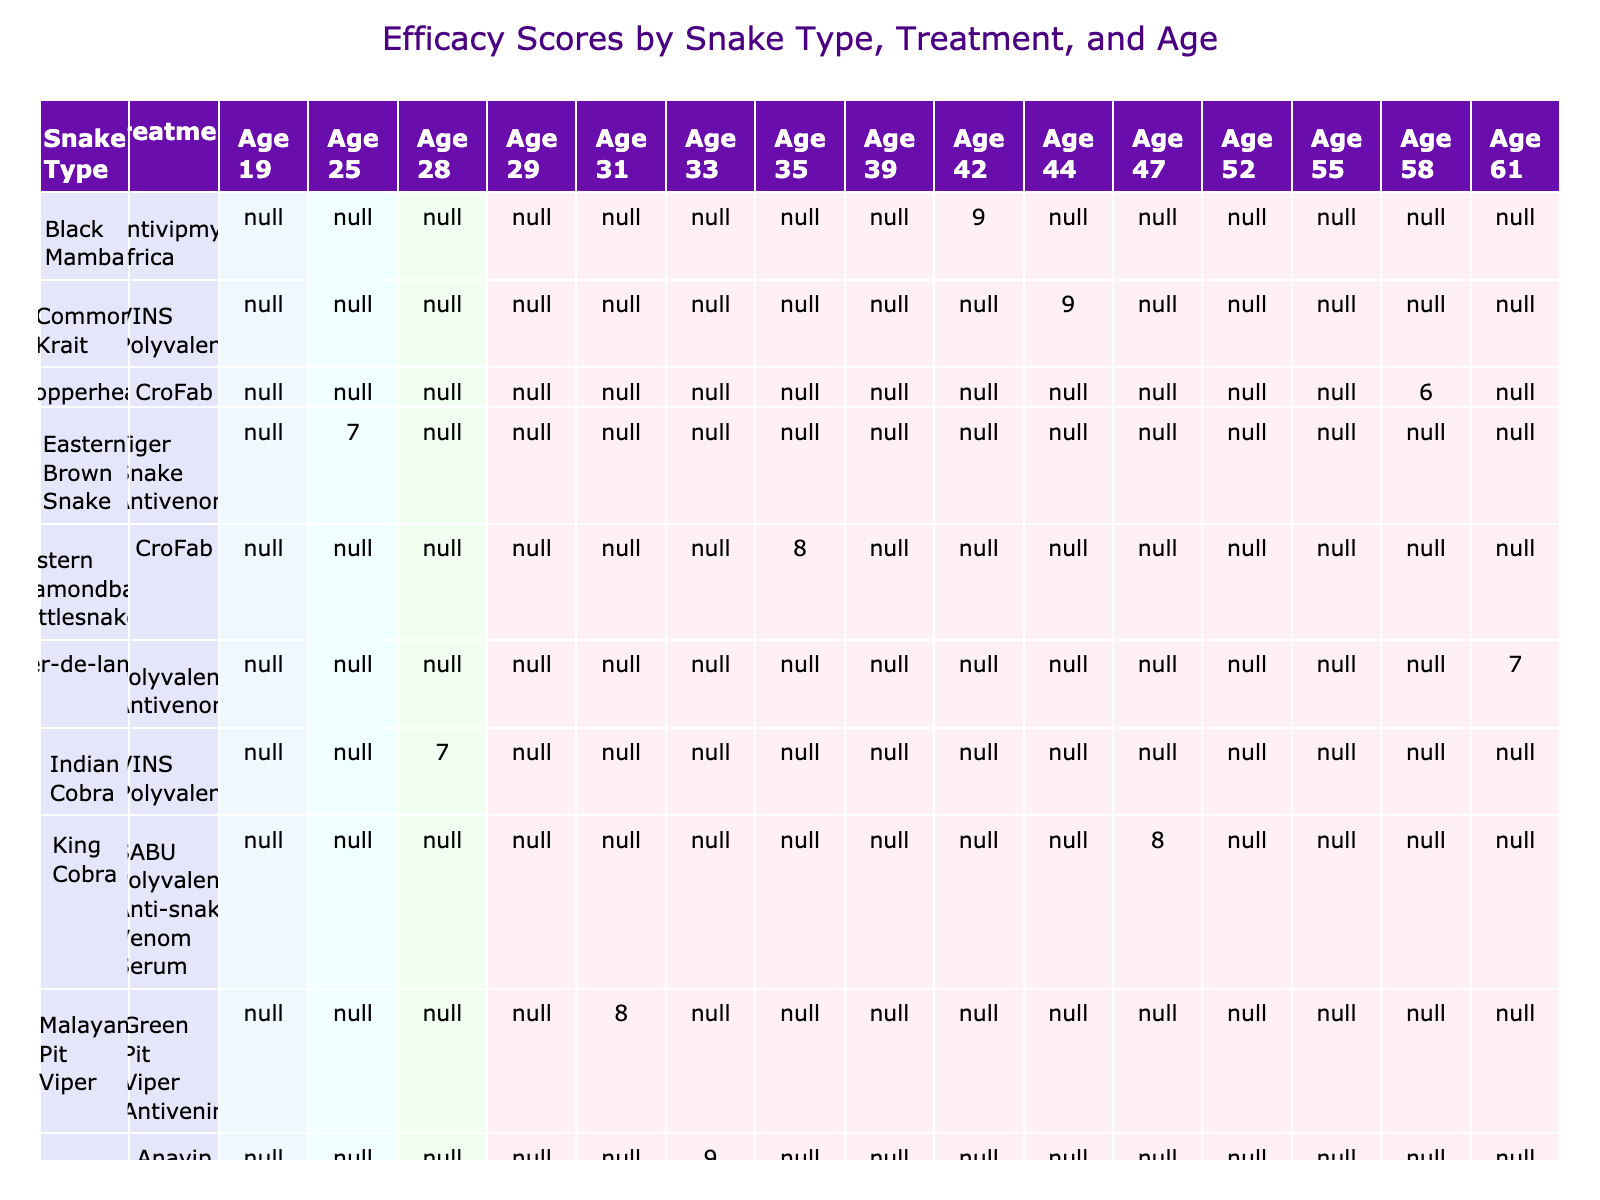What is the efficacy score for the Eastern Diamondback Rattlesnake treated with CroFab? The table shows the efficacy score for each treatment based on snake type. For the Eastern Diamondback Rattlesnake with treatment CroFab, the efficacy score is 8.
Answer: 8 Which treatment has the highest efficacy score for the Black Mamba? In the table, the Black Mamba is treated with Antivipmyn Africa and has an efficacy score of 9, which is the highest score noted for this snake type.
Answer: Antivipmyn Africa How many treatments have an efficacy score greater than 7? By reviewing the table, there are treatments (Antivipmyn Africa, Mojave Rattlesnake with Anavip, and Common Krait with VINS Polyvalent) that have efficacy scores greater than 7. There are a total of 5 treatments with scores higher than 7.
Answer: 5 What is the average efficacy score for treatments on Female patients? To find the average efficacy score for Female patients, we examine the efficacy scores for each treatment involving Female patients: 9 (Antivipmyn Africa, P002), 6 (CroFab, P004), 7 (Polyvalent Antivenom, P006), 8 (SABU Polyvalent, P008), 6 (CroFab, P014), and 7 (SAIMR Polyvalent, P012). Adding these scores gives 43, and dividing by the number of treatments (6), the average is 43/6 ≈ 7.17.
Answer: 7.17 Is there a treatment for the Indian Cobra in the table? The table shows that there is indeed a treatment for the Indian Cobra, which is VINS Polyvalent with an efficacy score of 7. Thus, the statement is true.
Answer: Yes What was the quickest recovery time (in hours) for any treatment recorded? By looking at the Recovery Times listed, the quickest recovery time is 18 hours from the treatment of the Black Mamba with Antivipmyn Africa (P002).
Answer: 18 Does the treatment Anavip yield a higher efficacy score than CroFab when dealing with a Mojave Rattlesnake? According to the table, Anavip for Mojave Rattlesnake has an efficacy score of 9, while CroFab (used for the Eastern Diamondback Rattlesnake) has a score of 8. Thus, Anavip yields a higher score.
Answer: Yes What is the difference in efficacy scores between the treatment for Russell's Viper and the Common Krait? The efficacy score for Russell's Viper (Snake Venom Antiserum IP) is 8, while for the Common Krait (VINS Polyvalent), it is 9. The difference between them is 9 - 8 = 1.
Answer: 1 